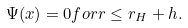Convert formula to latex. <formula><loc_0><loc_0><loc_500><loc_500>\Psi ( x ) = 0 f o r r \leq r _ { H } + h .</formula> 